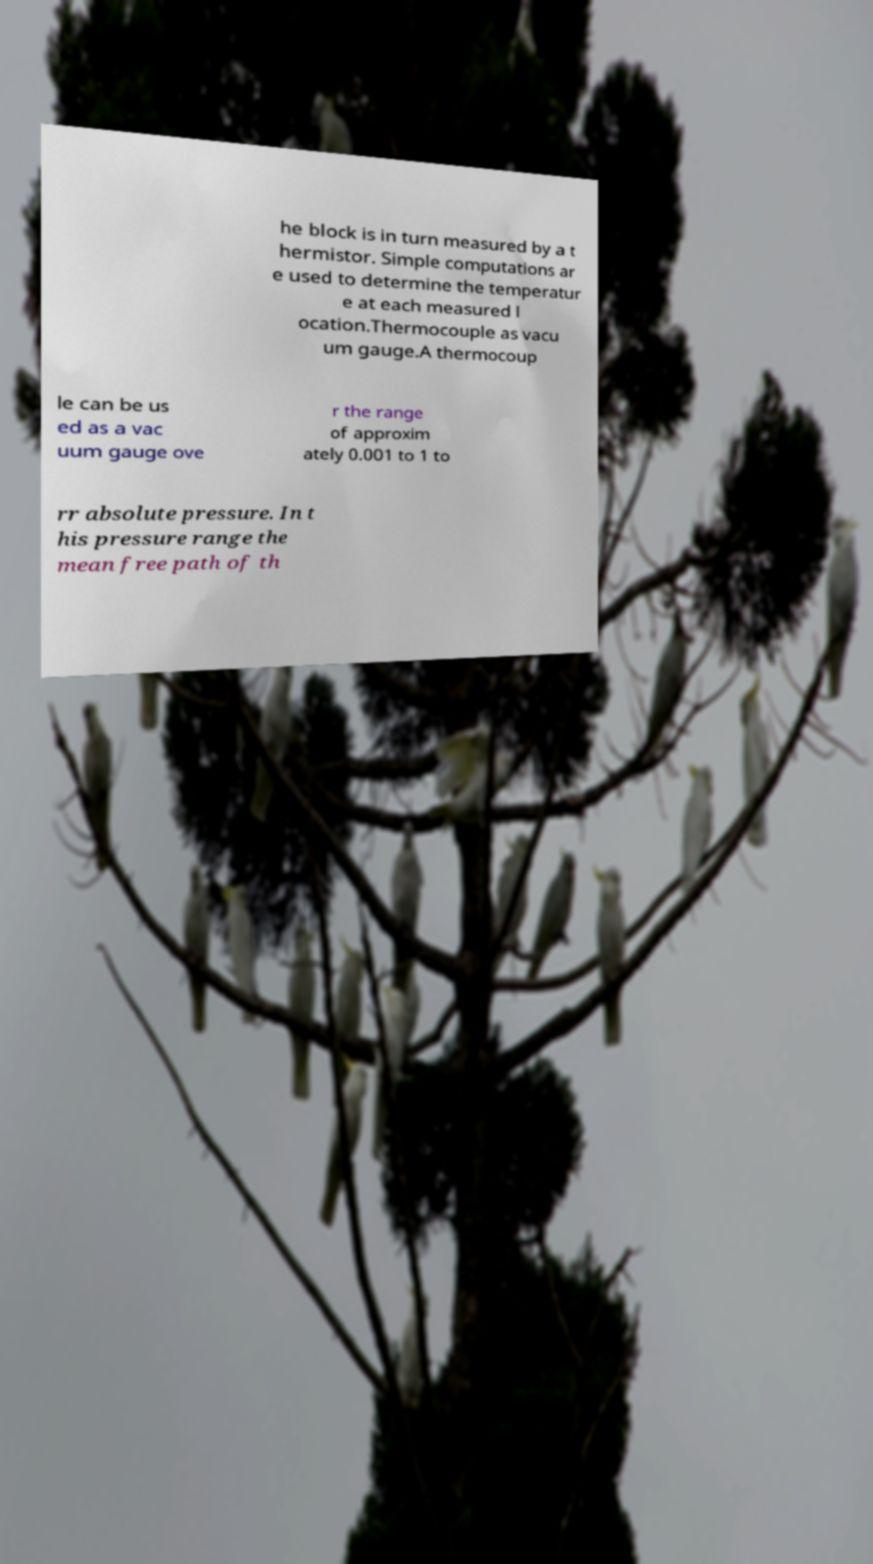Could you extract and type out the text from this image? he block is in turn measured by a t hermistor. Simple computations ar e used to determine the temperatur e at each measured l ocation.Thermocouple as vacu um gauge.A thermocoup le can be us ed as a vac uum gauge ove r the range of approxim ately 0.001 to 1 to rr absolute pressure. In t his pressure range the mean free path of th 